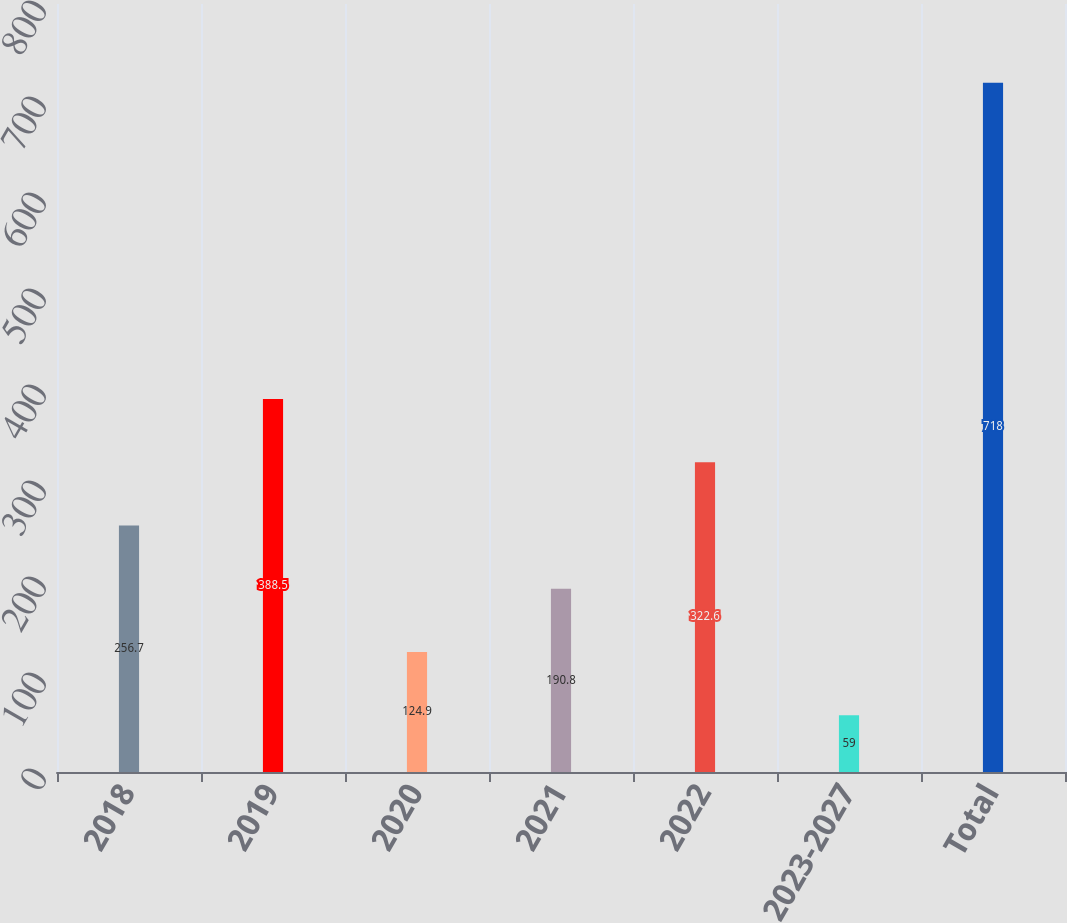<chart> <loc_0><loc_0><loc_500><loc_500><bar_chart><fcel>2018<fcel>2019<fcel>2020<fcel>2021<fcel>2022<fcel>2023-2027<fcel>Total<nl><fcel>256.7<fcel>388.5<fcel>124.9<fcel>190.8<fcel>322.6<fcel>59<fcel>718<nl></chart> 